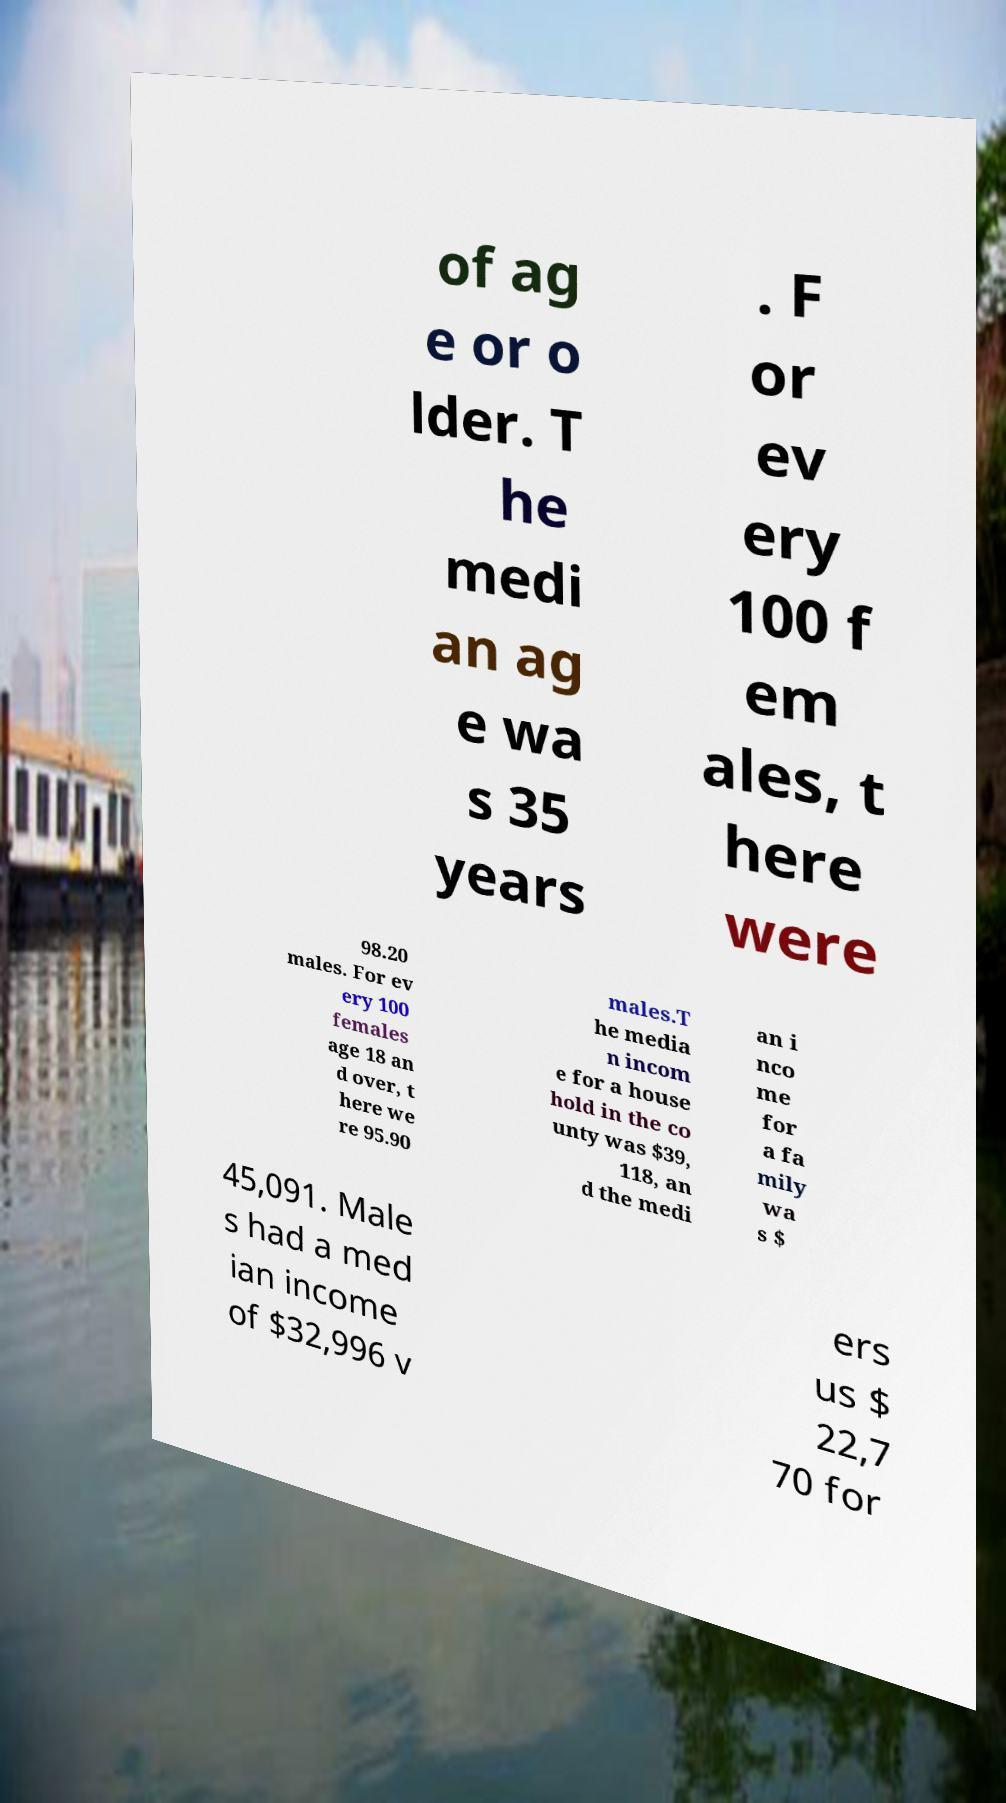Can you accurately transcribe the text from the provided image for me? of ag e or o lder. T he medi an ag e wa s 35 years . F or ev ery 100 f em ales, t here were 98.20 males. For ev ery 100 females age 18 an d over, t here we re 95.90 males.T he media n incom e for a house hold in the co unty was $39, 118, an d the medi an i nco me for a fa mily wa s $ 45,091. Male s had a med ian income of $32,996 v ers us $ 22,7 70 for 